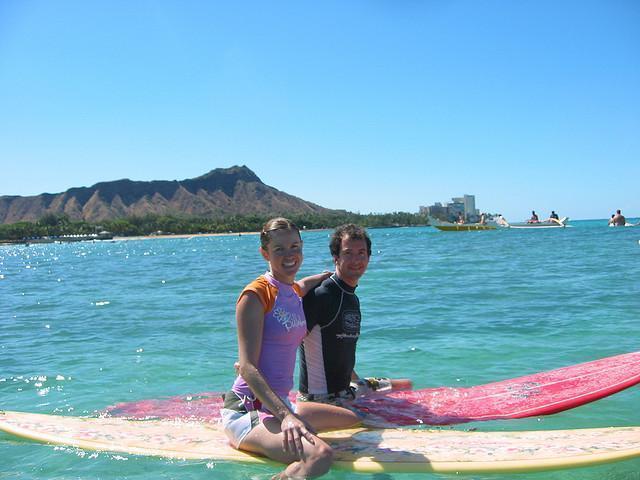How many surfboards are in the picture?
Give a very brief answer. 2. How many people are there?
Give a very brief answer. 2. 